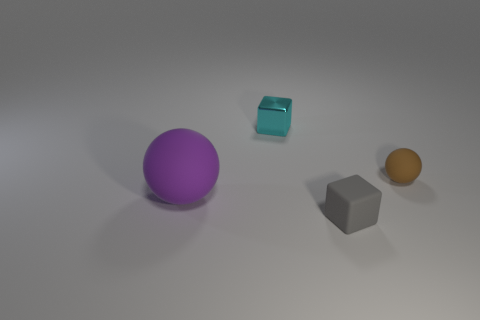What is the color of the small block that is made of the same material as the brown thing?
Provide a succinct answer. Gray. The brown thing has what size?
Offer a very short reply. Small. Is the number of rubber spheres in front of the tiny gray rubber object greater than the number of tiny cubes that are to the right of the small rubber ball?
Ensure brevity in your answer.  No. There is a tiny thing behind the small brown thing; what number of brown matte things are to the left of it?
Give a very brief answer. 0. There is a rubber thing in front of the purple rubber thing; does it have the same shape as the tiny shiny object?
Your response must be concise. Yes. What is the material of the other small gray thing that is the same shape as the small metal object?
Provide a succinct answer. Rubber. How many spheres have the same size as the gray matte cube?
Offer a very short reply. 1. There is a thing that is both on the right side of the cyan metal cube and behind the rubber cube; what color is it?
Your response must be concise. Brown. Are there fewer tiny brown spheres than things?
Offer a terse response. Yes. There is a metallic block; does it have the same color as the ball that is to the right of the big purple object?
Provide a short and direct response. No. 